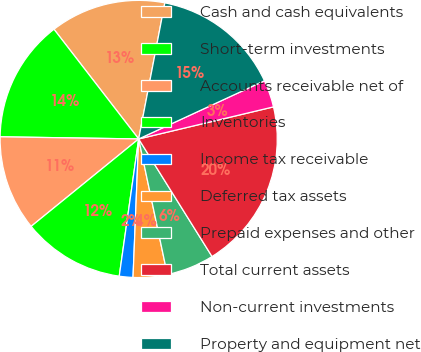Convert chart. <chart><loc_0><loc_0><loc_500><loc_500><pie_chart><fcel>Cash and cash equivalents<fcel>Short-term investments<fcel>Accounts receivable net of<fcel>Inventories<fcel>Income tax receivable<fcel>Deferred tax assets<fcel>Prepaid expenses and other<fcel>Total current assets<fcel>Non-current investments<fcel>Property and equipment net<nl><fcel>13.49%<fcel>14.29%<fcel>11.11%<fcel>11.9%<fcel>1.59%<fcel>3.97%<fcel>5.56%<fcel>19.84%<fcel>3.18%<fcel>15.08%<nl></chart> 